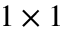<formula> <loc_0><loc_0><loc_500><loc_500>1 \times 1</formula> 